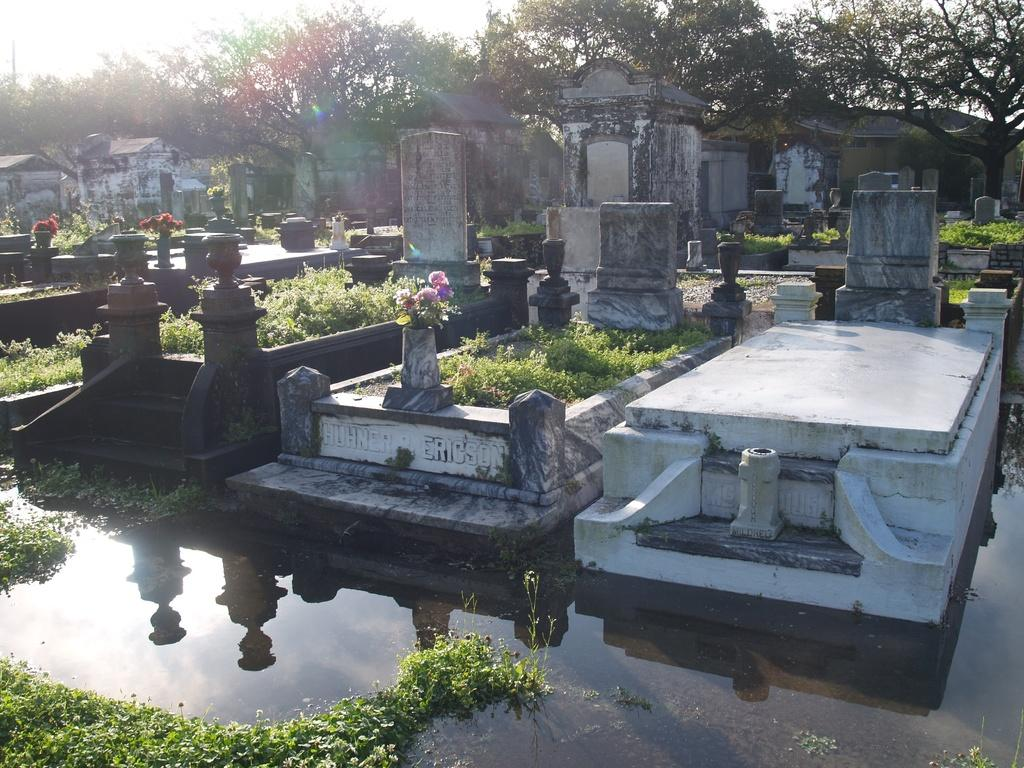What type of structures can be seen in the image? There are buildings in the image. What natural elements are present in the image? There are plants, flowers, trees, and water visible on the ground in the image. What is the condition of the sky in the image? The sky is cloudy in the image. Can you see the coastline in the image? There is no coastline visible in the image. What type of form does the water take in the image? The water is visible on the ground in the image, but its form is not specified. Is there an airplane in the image? There is no airplane present in the image. 